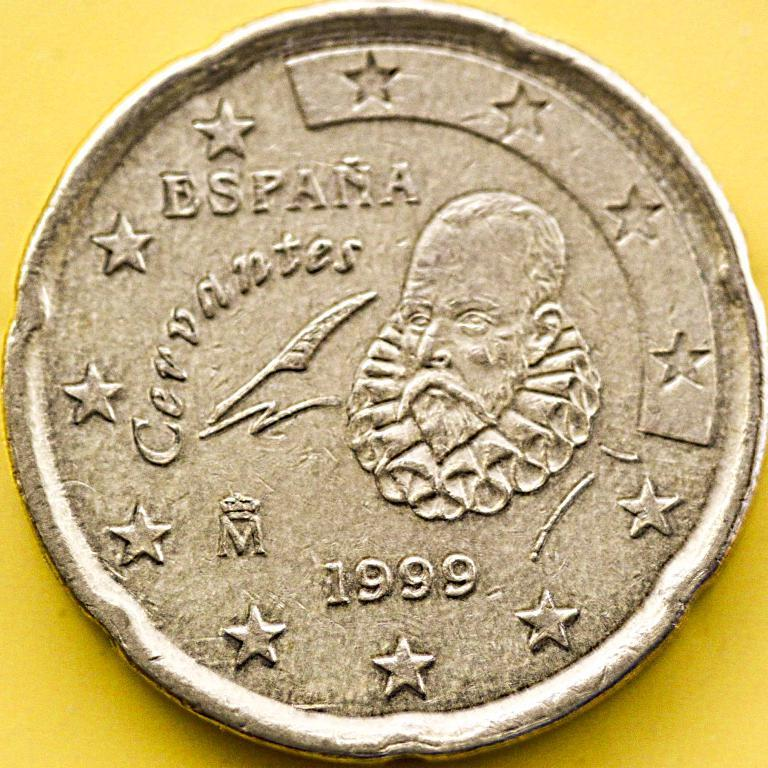<image>
Give a short and clear explanation of the subsequent image. A coin with a man on it also has the year 1999. 